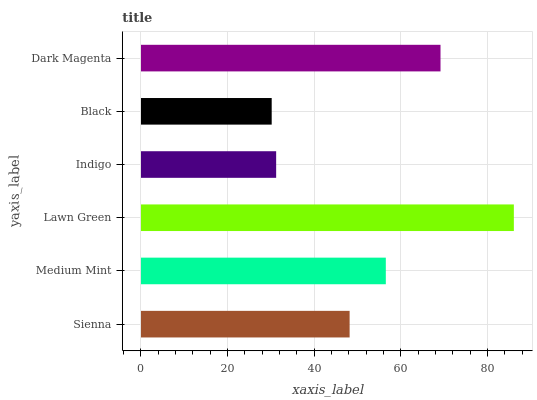Is Black the minimum?
Answer yes or no. Yes. Is Lawn Green the maximum?
Answer yes or no. Yes. Is Medium Mint the minimum?
Answer yes or no. No. Is Medium Mint the maximum?
Answer yes or no. No. Is Medium Mint greater than Sienna?
Answer yes or no. Yes. Is Sienna less than Medium Mint?
Answer yes or no. Yes. Is Sienna greater than Medium Mint?
Answer yes or no. No. Is Medium Mint less than Sienna?
Answer yes or no. No. Is Medium Mint the high median?
Answer yes or no. Yes. Is Sienna the low median?
Answer yes or no. Yes. Is Sienna the high median?
Answer yes or no. No. Is Medium Mint the low median?
Answer yes or no. No. 